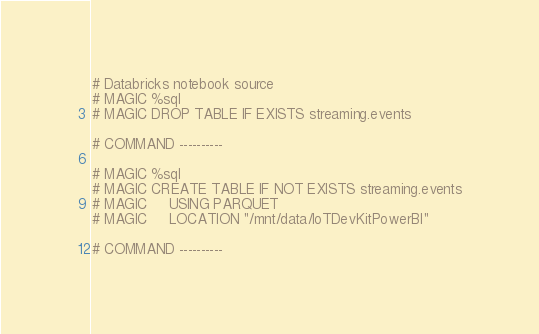<code> <loc_0><loc_0><loc_500><loc_500><_Python_># Databricks notebook source
# MAGIC %sql
# MAGIC DROP TABLE IF EXISTS streaming.events

# COMMAND ----------

# MAGIC %sql
# MAGIC CREATE TABLE IF NOT EXISTS streaming.events
# MAGIC     USING PARQUET
# MAGIC     LOCATION "/mnt/data/IoTDevKitPowerBI"

# COMMAND ----------

</code> 